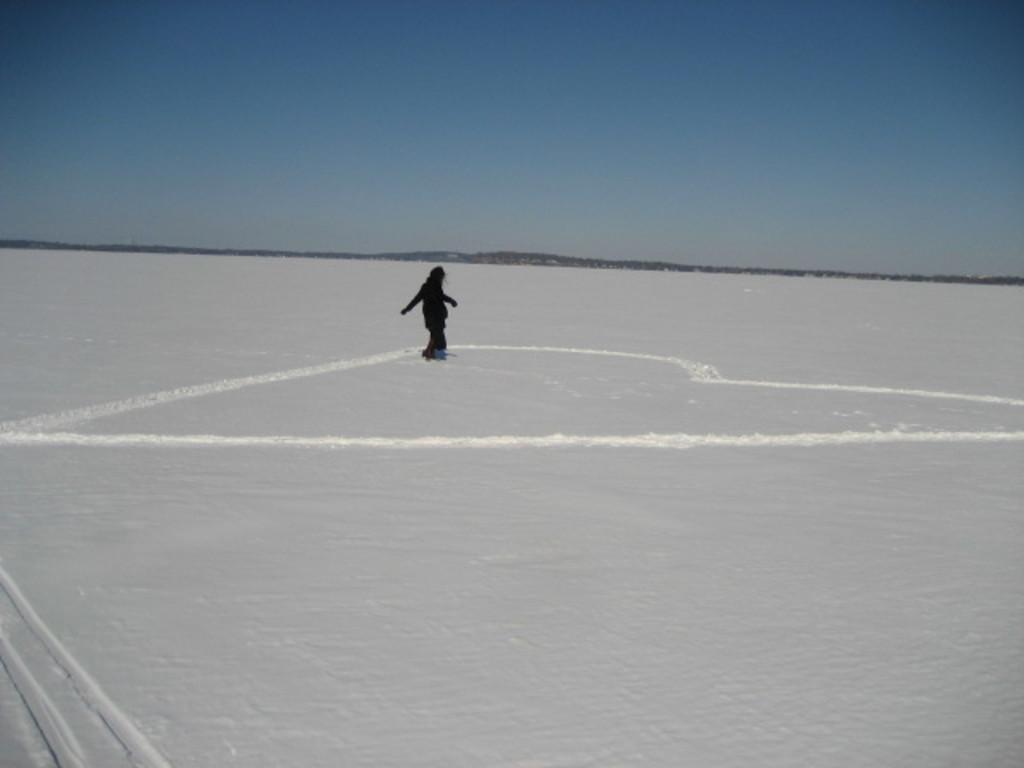Describe this image in one or two sentences. There is one person skating on a snowy ground as we can see in the middle of this image, and there is a sky at the top of this image. 